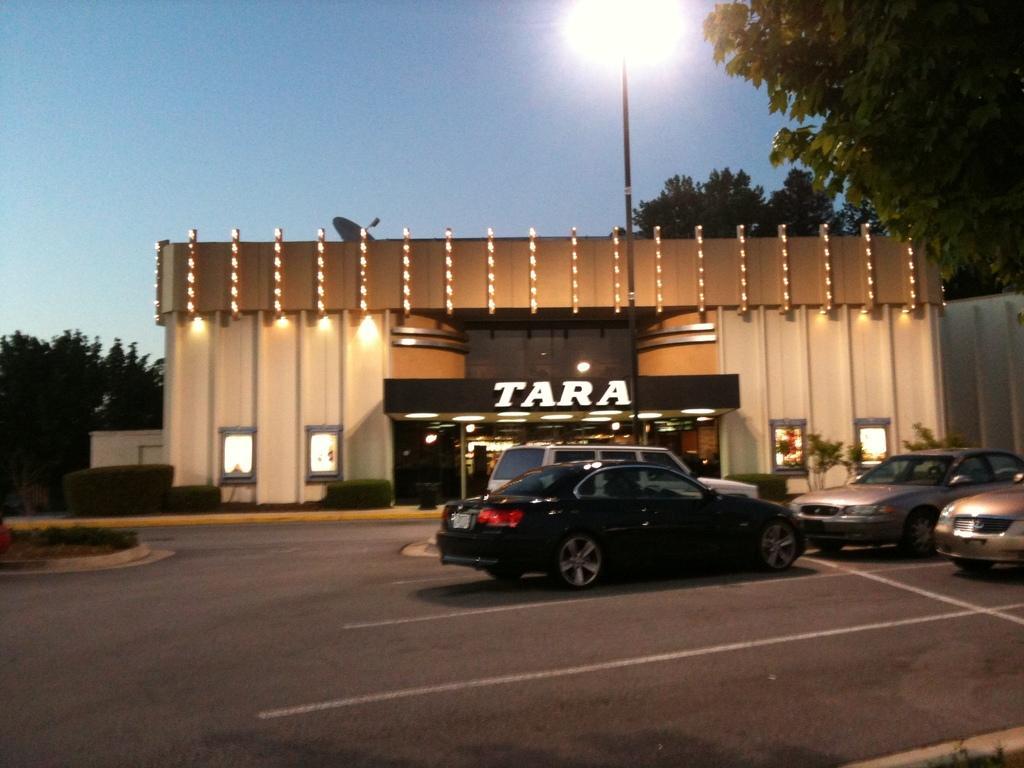Describe this image in one or two sentences. In this picture we can see some vehicles parked on the road and behind the vehicles there is a shop and on top of the shop there is an antenna and behind the shop there are trees, a pole with a light and sky. 